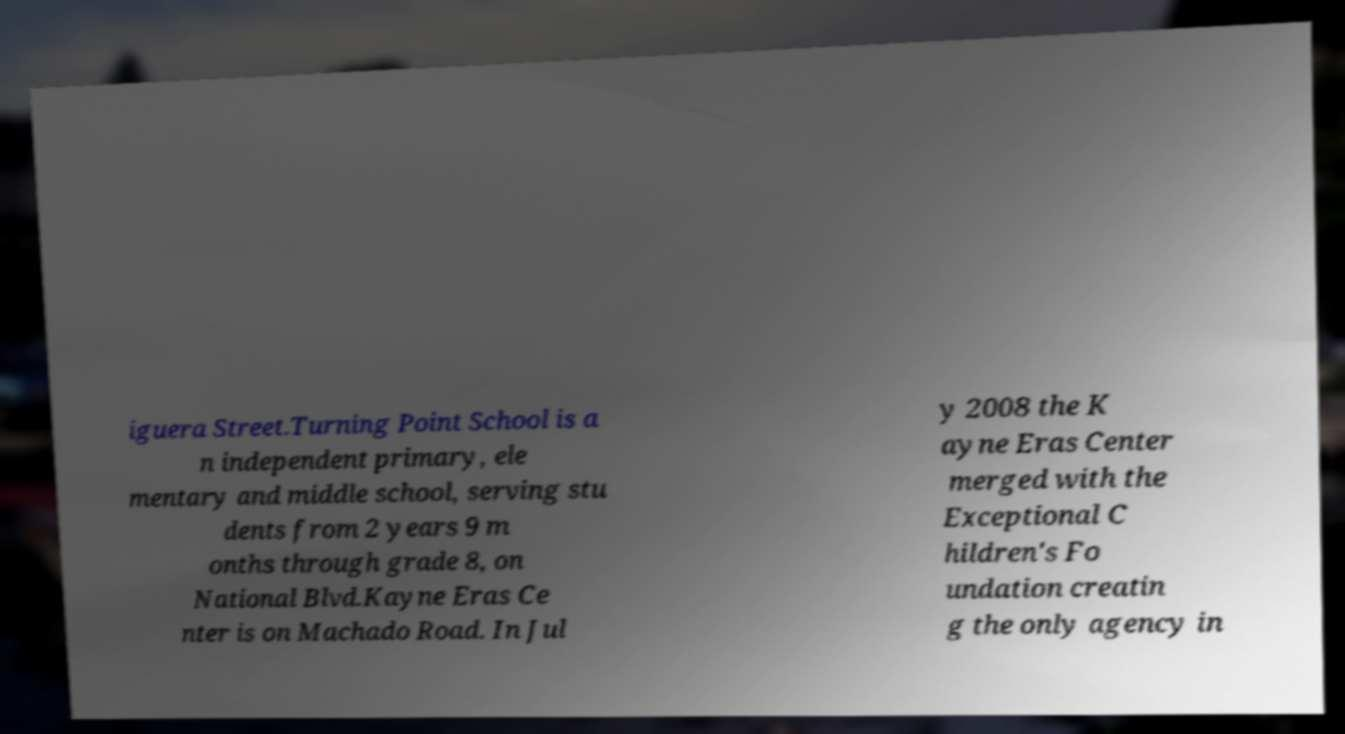For documentation purposes, I need the text within this image transcribed. Could you provide that? iguera Street.Turning Point School is a n independent primary, ele mentary and middle school, serving stu dents from 2 years 9 m onths through grade 8, on National Blvd.Kayne Eras Ce nter is on Machado Road. In Jul y 2008 the K ayne Eras Center merged with the Exceptional C hildren's Fo undation creatin g the only agency in 